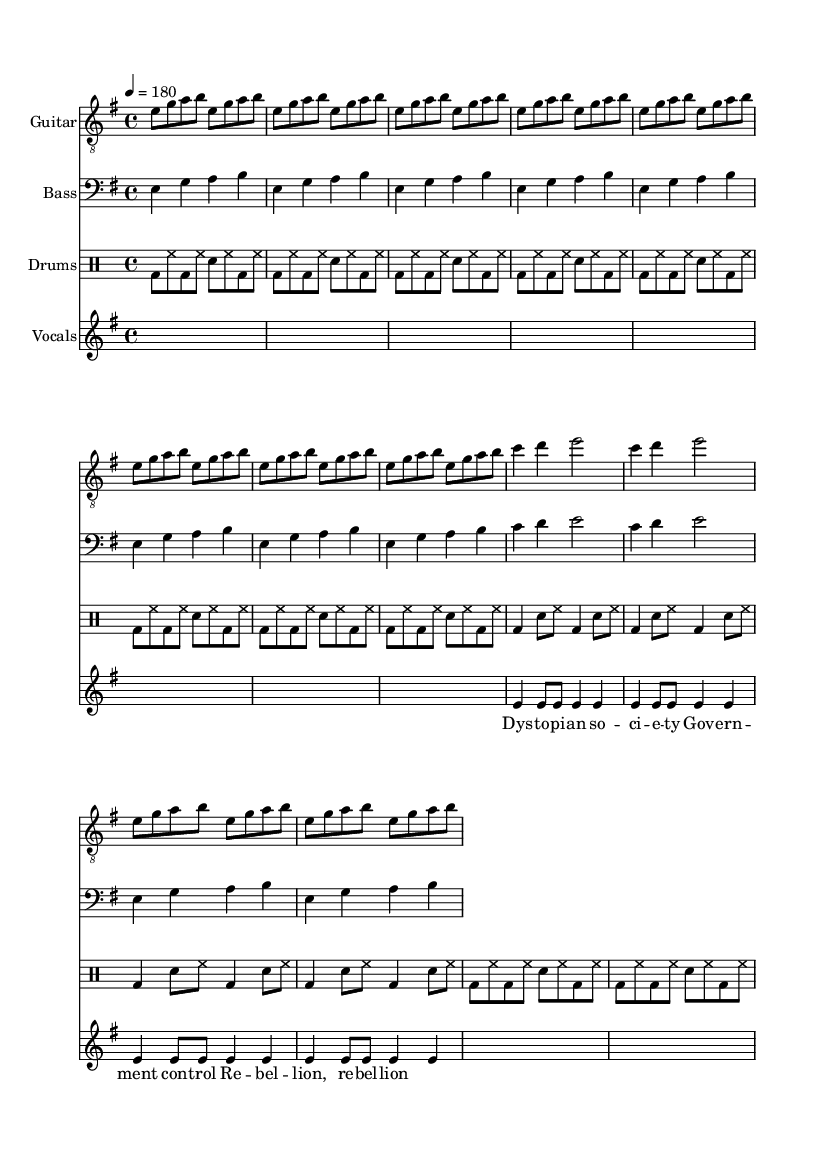What is the key signature of this music? The key signature shows one sharp, which indicates that the music is in E minor.
Answer: E minor What is the time signature of this music? The time signature is indicated at the beginning of the score. It displays a 4 over 4, meaning four beats per measure.
Answer: 4/4 What is the tempo marking of this music? The tempo marking indicates a speed of 180 beats per minute, which is a fast tempo typical for hardcore punk.
Answer: 180 How many times is the guitar riff repeated? The guitar riff is repeated a total of four times, as indicated by the repeat unfolded notation in the music.
Answer: 4 What is the main lyrical theme in the vocals? The lyrics mention "Dystopian society" and themes of "government control," which are central to the song's message.
Answer: Dystopian society How many measures are in the drum pattern played before the variation? The drum pattern is repeated eight times in the score, indicating it lasts for eight measures before shifting to a different rhythm.
Answer: 8 What is the primary vocal technique indicated in this sheet music? The use of 's' (silence) indicates there are sections without vocals, which is common in punk music for emphasis or breaks.
Answer: Silence 